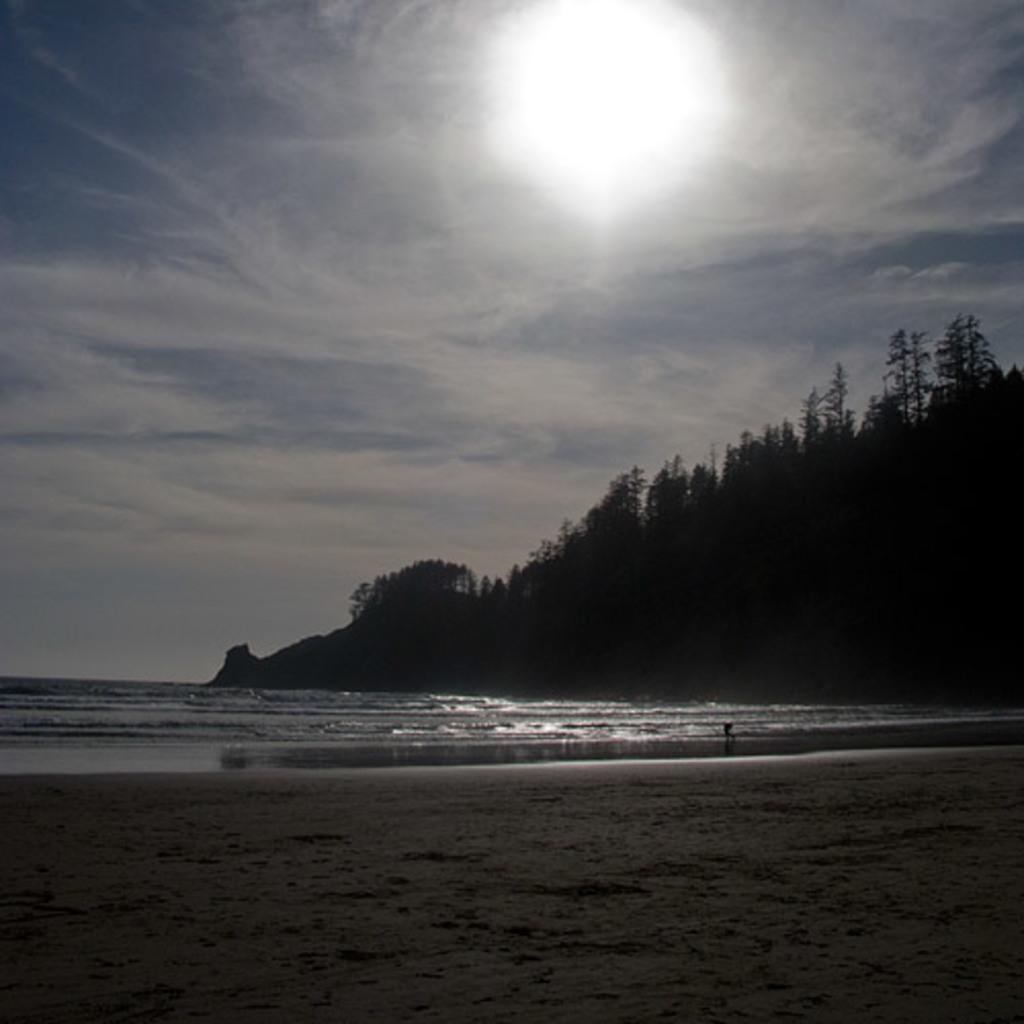What type of terrain is visible in the image? There is ground visible in the image. What natural element is also present in the image? There is water visible in the image. What type of vegetation can be seen in the image? There are trees in the image. What can be seen in the background of the image? The sky is visible in the background of the image, and the sun is also visible. How much money is being exchanged between the trees in the image? There is no money being exchanged in the image; it features natural elements such as ground, water, trees, sky, and the sun. 